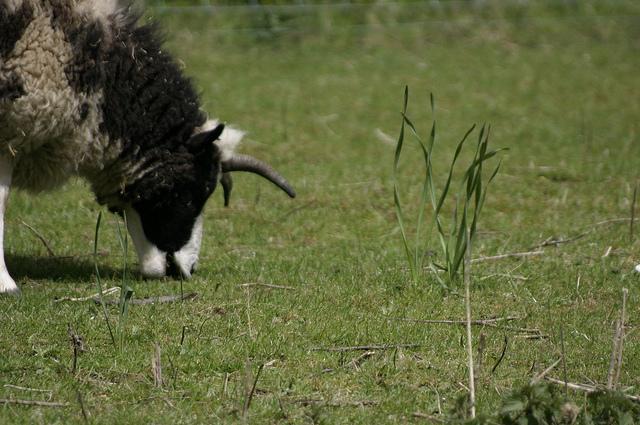What animal is this?
Short answer required. Goat. What is the color of the grass?
Concise answer only. Green. What is the animal doing?
Write a very short answer. Eating. What kind of animal is pictured?
Keep it brief. Goat. 